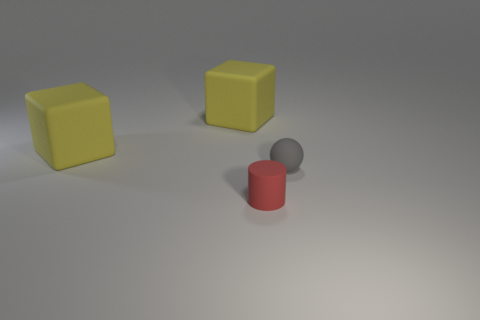Add 3 cylinders. How many objects exist? 7 Subtract all cylinders. How many objects are left? 3 Subtract 1 red cylinders. How many objects are left? 3 Subtract all big blue matte cylinders. Subtract all yellow cubes. How many objects are left? 2 Add 1 small gray matte things. How many small gray matte things are left? 2 Add 4 big brown rubber blocks. How many big brown rubber blocks exist? 4 